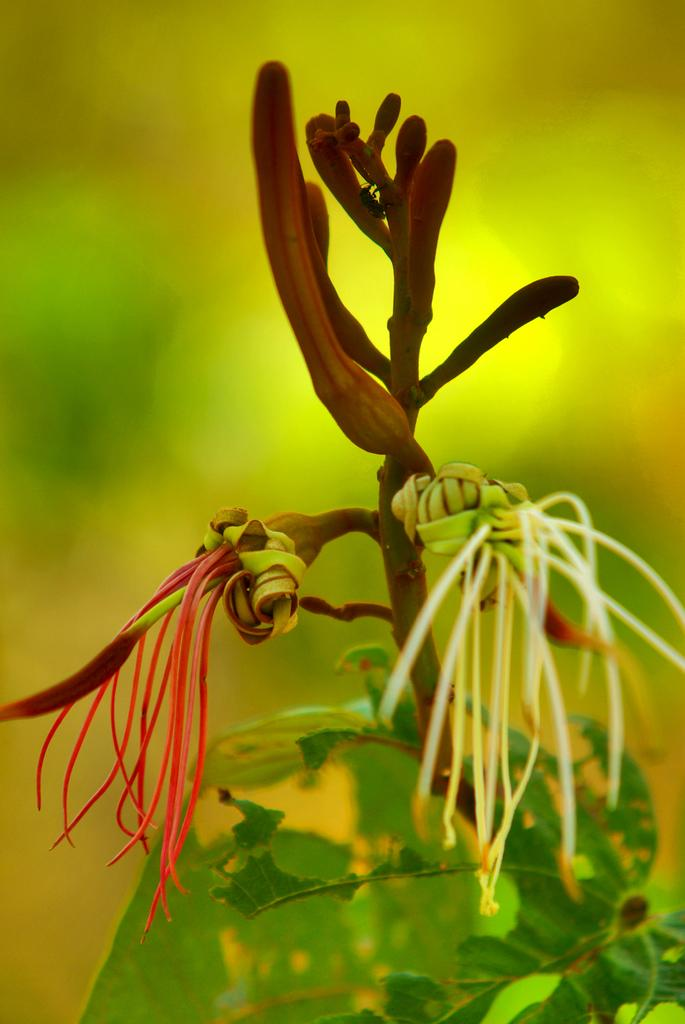What type of plant can be seen in the image? There is a plant with buds in the image. Can you describe the background of the image? The background of the image is blurry. Is there a beginner gardener in the image? There is no indication of a person, let alone a beginner gardener, in the image. 